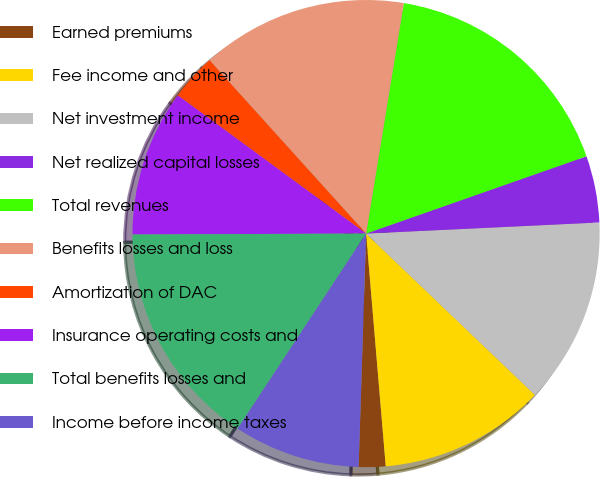Convert chart to OTSL. <chart><loc_0><loc_0><loc_500><loc_500><pie_chart><fcel>Earned premiums<fcel>Fee income and other<fcel>Net investment income<fcel>Net realized capital losses<fcel>Total revenues<fcel>Benefits losses and loss<fcel>Amortization of DAC<fcel>Insurance operating costs and<fcel>Total benefits losses and<fcel>Income before income taxes<nl><fcel>1.85%<fcel>11.52%<fcel>12.9%<fcel>4.61%<fcel>17.05%<fcel>14.28%<fcel>3.23%<fcel>10.14%<fcel>15.67%<fcel>8.76%<nl></chart> 